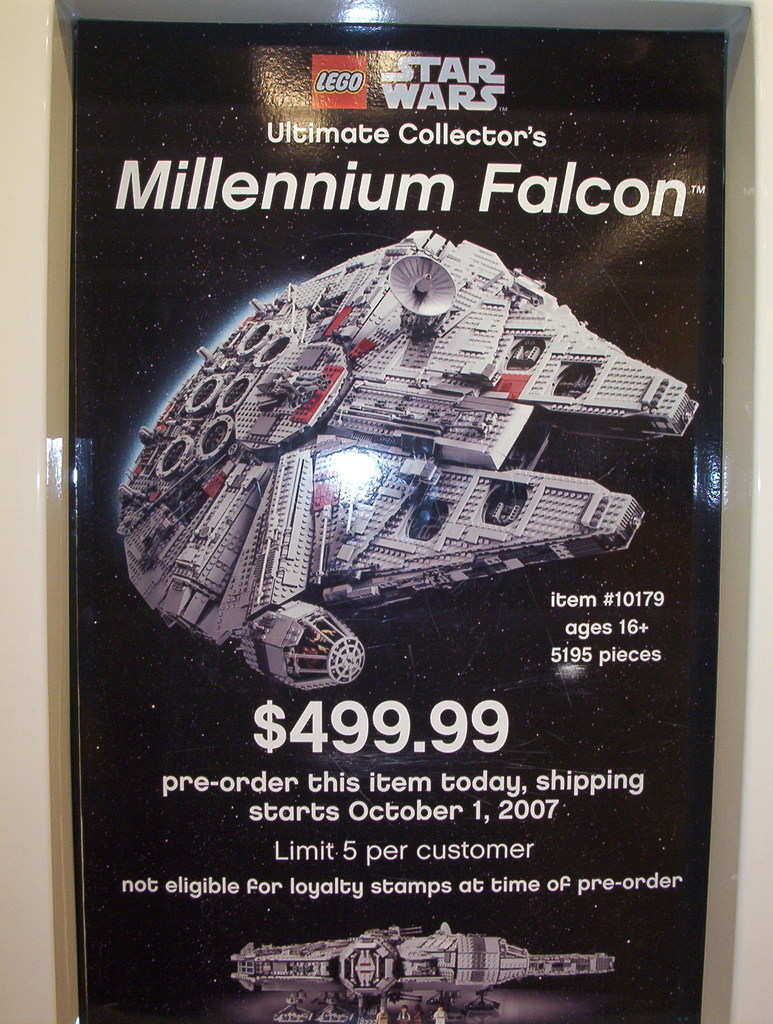Describe the specific features of the Lego Millennium Falcon. The Lego Millennium Falcon as depicted features intricate details including satellite dishes, laser cannons, and an overall detailed grey paneling that mimics the infamous ship from Star Wars. The set, designed for older builders, includes complex internal structures and removable panels to reveal the interior. 